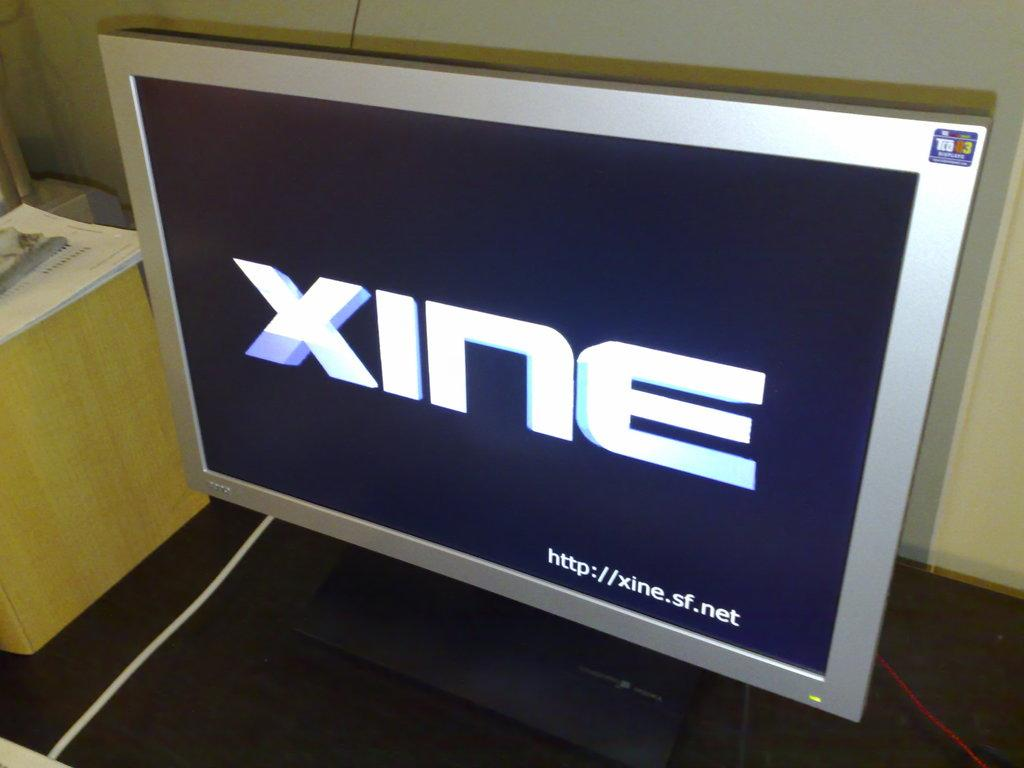<image>
Summarize the visual content of the image. Computer screen which says XINE on it in white. 